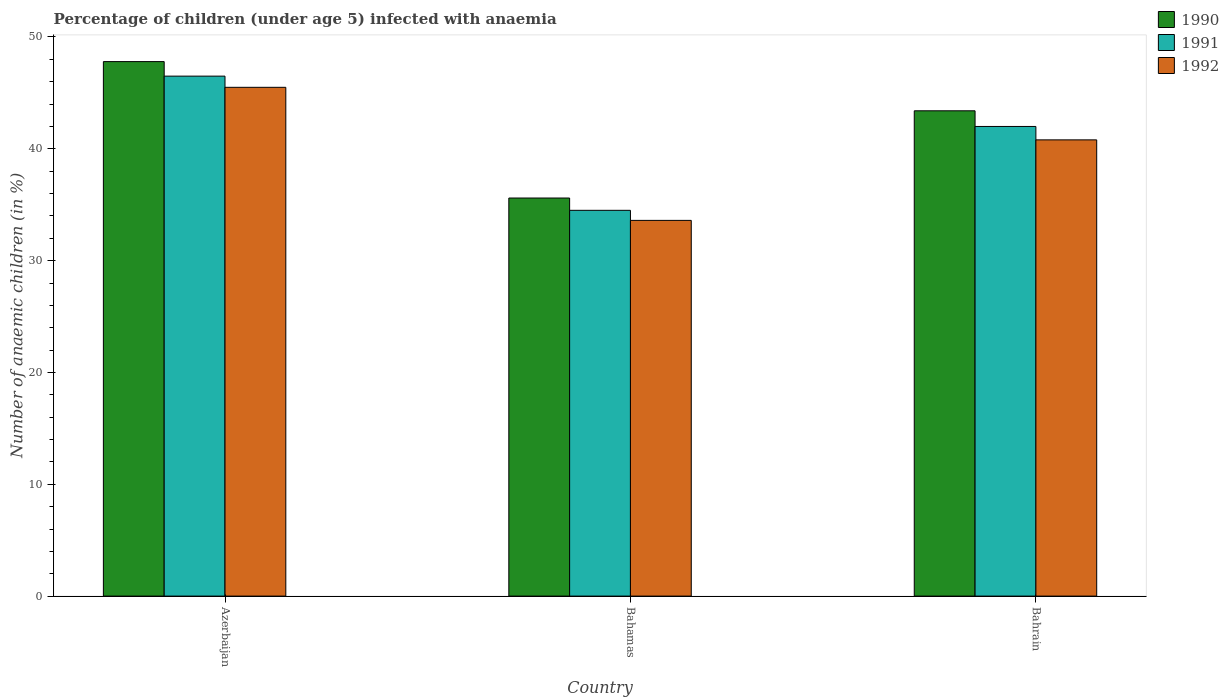How many groups of bars are there?
Ensure brevity in your answer.  3. What is the label of the 2nd group of bars from the left?
Offer a very short reply. Bahamas. What is the percentage of children infected with anaemia in in 1992 in Bahamas?
Your answer should be compact. 33.6. Across all countries, what is the maximum percentage of children infected with anaemia in in 1990?
Provide a short and direct response. 47.8. Across all countries, what is the minimum percentage of children infected with anaemia in in 1990?
Provide a short and direct response. 35.6. In which country was the percentage of children infected with anaemia in in 1991 maximum?
Your answer should be compact. Azerbaijan. In which country was the percentage of children infected with anaemia in in 1991 minimum?
Keep it short and to the point. Bahamas. What is the total percentage of children infected with anaemia in in 1991 in the graph?
Give a very brief answer. 123. What is the difference between the percentage of children infected with anaemia in in 1992 in Azerbaijan and that in Bahamas?
Make the answer very short. 11.9. What is the difference between the percentage of children infected with anaemia in in 1991 in Azerbaijan and the percentage of children infected with anaemia in in 1992 in Bahamas?
Your answer should be very brief. 12.9. What is the average percentage of children infected with anaemia in in 1990 per country?
Your answer should be very brief. 42.27. What is the difference between the percentage of children infected with anaemia in of/in 1990 and percentage of children infected with anaemia in of/in 1991 in Bahrain?
Provide a short and direct response. 1.4. In how many countries, is the percentage of children infected with anaemia in in 1990 greater than 16 %?
Your response must be concise. 3. What is the ratio of the percentage of children infected with anaemia in in 1990 in Bahamas to that in Bahrain?
Your answer should be very brief. 0.82. What is the difference between the highest and the second highest percentage of children infected with anaemia in in 1992?
Provide a short and direct response. 7.2. What is the difference between the highest and the lowest percentage of children infected with anaemia in in 1992?
Your response must be concise. 11.9. In how many countries, is the percentage of children infected with anaemia in in 1990 greater than the average percentage of children infected with anaemia in in 1990 taken over all countries?
Provide a short and direct response. 2. What does the 3rd bar from the left in Azerbaijan represents?
Provide a succinct answer. 1992. What does the 2nd bar from the right in Azerbaijan represents?
Offer a very short reply. 1991. Are all the bars in the graph horizontal?
Offer a terse response. No. How many countries are there in the graph?
Your answer should be compact. 3. Are the values on the major ticks of Y-axis written in scientific E-notation?
Your answer should be very brief. No. Does the graph contain grids?
Offer a very short reply. No. How many legend labels are there?
Offer a very short reply. 3. What is the title of the graph?
Keep it short and to the point. Percentage of children (under age 5) infected with anaemia. Does "1991" appear as one of the legend labels in the graph?
Ensure brevity in your answer.  Yes. What is the label or title of the Y-axis?
Give a very brief answer. Number of anaemic children (in %). What is the Number of anaemic children (in %) of 1990 in Azerbaijan?
Offer a terse response. 47.8. What is the Number of anaemic children (in %) in 1991 in Azerbaijan?
Keep it short and to the point. 46.5. What is the Number of anaemic children (in %) in 1992 in Azerbaijan?
Make the answer very short. 45.5. What is the Number of anaemic children (in %) in 1990 in Bahamas?
Offer a very short reply. 35.6. What is the Number of anaemic children (in %) in 1991 in Bahamas?
Make the answer very short. 34.5. What is the Number of anaemic children (in %) of 1992 in Bahamas?
Keep it short and to the point. 33.6. What is the Number of anaemic children (in %) in 1990 in Bahrain?
Your answer should be compact. 43.4. What is the Number of anaemic children (in %) in 1992 in Bahrain?
Your answer should be compact. 40.8. Across all countries, what is the maximum Number of anaemic children (in %) of 1990?
Give a very brief answer. 47.8. Across all countries, what is the maximum Number of anaemic children (in %) in 1991?
Keep it short and to the point. 46.5. Across all countries, what is the maximum Number of anaemic children (in %) of 1992?
Your answer should be very brief. 45.5. Across all countries, what is the minimum Number of anaemic children (in %) of 1990?
Offer a terse response. 35.6. Across all countries, what is the minimum Number of anaemic children (in %) in 1991?
Offer a very short reply. 34.5. Across all countries, what is the minimum Number of anaemic children (in %) of 1992?
Offer a terse response. 33.6. What is the total Number of anaemic children (in %) of 1990 in the graph?
Offer a terse response. 126.8. What is the total Number of anaemic children (in %) in 1991 in the graph?
Make the answer very short. 123. What is the total Number of anaemic children (in %) in 1992 in the graph?
Your answer should be very brief. 119.9. What is the difference between the Number of anaemic children (in %) in 1990 in Azerbaijan and that in Bahamas?
Provide a short and direct response. 12.2. What is the difference between the Number of anaemic children (in %) in 1992 in Azerbaijan and that in Bahamas?
Your response must be concise. 11.9. What is the difference between the Number of anaemic children (in %) of 1990 in Bahamas and that in Bahrain?
Ensure brevity in your answer.  -7.8. What is the difference between the Number of anaemic children (in %) in 1991 in Bahamas and that in Bahrain?
Offer a very short reply. -7.5. What is the difference between the Number of anaemic children (in %) of 1992 in Bahamas and that in Bahrain?
Provide a short and direct response. -7.2. What is the difference between the Number of anaemic children (in %) in 1990 in Azerbaijan and the Number of anaemic children (in %) in 1992 in Bahamas?
Provide a short and direct response. 14.2. What is the difference between the Number of anaemic children (in %) of 1991 in Azerbaijan and the Number of anaemic children (in %) of 1992 in Bahamas?
Keep it short and to the point. 12.9. What is the difference between the Number of anaemic children (in %) in 1990 in Azerbaijan and the Number of anaemic children (in %) in 1992 in Bahrain?
Ensure brevity in your answer.  7. What is the difference between the Number of anaemic children (in %) in 1990 in Bahamas and the Number of anaemic children (in %) in 1991 in Bahrain?
Ensure brevity in your answer.  -6.4. What is the difference between the Number of anaemic children (in %) in 1990 in Bahamas and the Number of anaemic children (in %) in 1992 in Bahrain?
Provide a succinct answer. -5.2. What is the difference between the Number of anaemic children (in %) in 1991 in Bahamas and the Number of anaemic children (in %) in 1992 in Bahrain?
Make the answer very short. -6.3. What is the average Number of anaemic children (in %) of 1990 per country?
Your answer should be very brief. 42.27. What is the average Number of anaemic children (in %) of 1991 per country?
Offer a terse response. 41. What is the average Number of anaemic children (in %) in 1992 per country?
Your answer should be compact. 39.97. What is the difference between the Number of anaemic children (in %) in 1990 and Number of anaemic children (in %) in 1991 in Azerbaijan?
Make the answer very short. 1.3. What is the difference between the Number of anaemic children (in %) in 1990 and Number of anaemic children (in %) in 1992 in Azerbaijan?
Keep it short and to the point. 2.3. What is the difference between the Number of anaemic children (in %) of 1990 and Number of anaemic children (in %) of 1991 in Bahrain?
Provide a succinct answer. 1.4. What is the difference between the Number of anaemic children (in %) of 1990 and Number of anaemic children (in %) of 1992 in Bahrain?
Your answer should be compact. 2.6. What is the ratio of the Number of anaemic children (in %) in 1990 in Azerbaijan to that in Bahamas?
Make the answer very short. 1.34. What is the ratio of the Number of anaemic children (in %) in 1991 in Azerbaijan to that in Bahamas?
Give a very brief answer. 1.35. What is the ratio of the Number of anaemic children (in %) in 1992 in Azerbaijan to that in Bahamas?
Offer a terse response. 1.35. What is the ratio of the Number of anaemic children (in %) in 1990 in Azerbaijan to that in Bahrain?
Make the answer very short. 1.1. What is the ratio of the Number of anaemic children (in %) in 1991 in Azerbaijan to that in Bahrain?
Make the answer very short. 1.11. What is the ratio of the Number of anaemic children (in %) in 1992 in Azerbaijan to that in Bahrain?
Give a very brief answer. 1.12. What is the ratio of the Number of anaemic children (in %) of 1990 in Bahamas to that in Bahrain?
Make the answer very short. 0.82. What is the ratio of the Number of anaemic children (in %) in 1991 in Bahamas to that in Bahrain?
Make the answer very short. 0.82. What is the ratio of the Number of anaemic children (in %) of 1992 in Bahamas to that in Bahrain?
Make the answer very short. 0.82. What is the difference between the highest and the second highest Number of anaemic children (in %) of 1990?
Keep it short and to the point. 4.4. What is the difference between the highest and the second highest Number of anaemic children (in %) in 1992?
Provide a succinct answer. 4.7. What is the difference between the highest and the lowest Number of anaemic children (in %) in 1991?
Give a very brief answer. 12. 